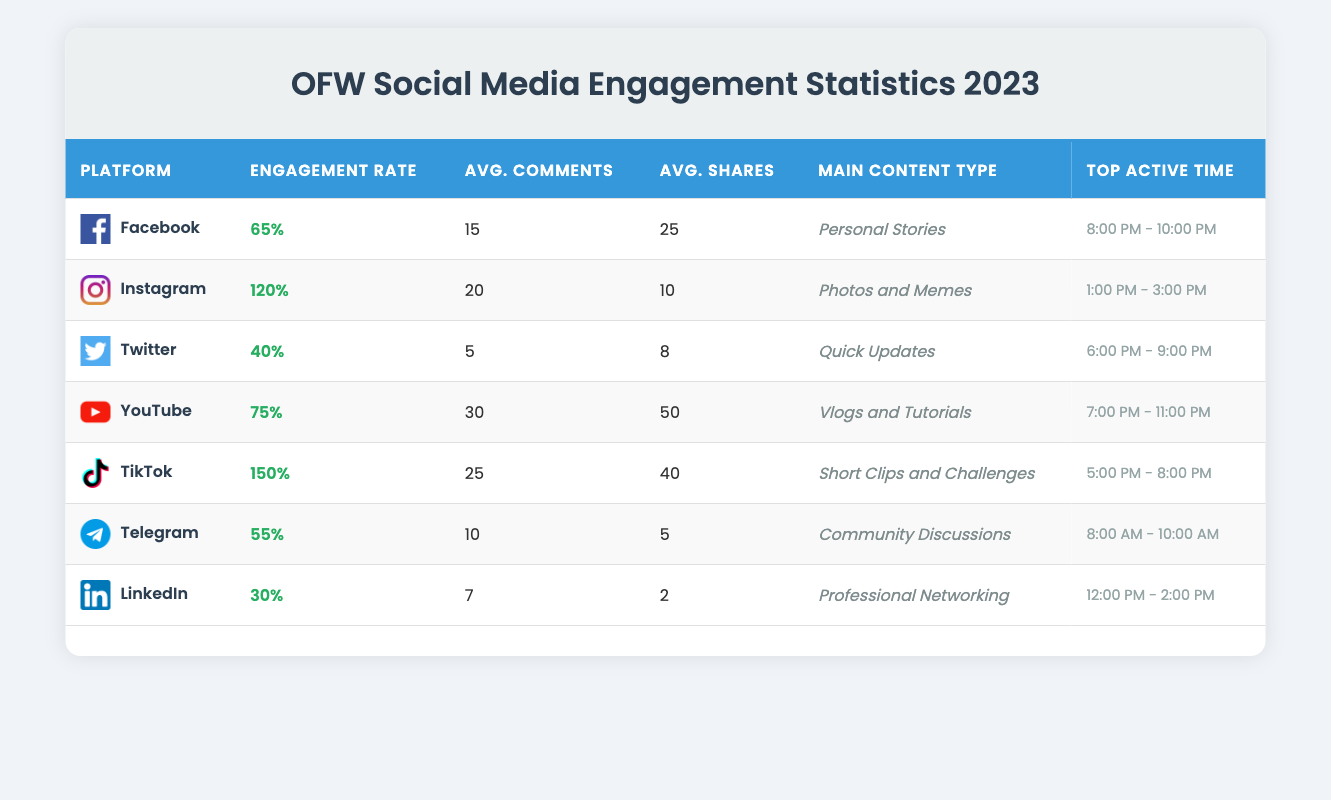What's the engagement rate for TikTok? Referring to the table, TikTok has an engagement rate listed as 1.5 or 150%.
Answer: 150% Which platform has the highest average comments per post? By examining the table, we see that YouTube has the highest average comments per video, which is 30.
Answer: 30 Is the main content type for Twitter quick updates? The table indicates that the main content type for Twitter is indeed Quick Updates.
Answer: Yes What is the average engagement rate for Facebook and Instagram combined? The engagement rates for Facebook and Instagram are 0.65 (65%) and 1.2 (120%), respectively. Summing these gives 0.65 + 1.2 = 1.85. To find the average, divide by 2: 1.85 / 2 = 0.925 or 92.5%.
Answer: 92.5% During which time range is Telegram most active? According to the table, Telegram's top active time is from 8:00 AM to 10:00 AM.
Answer: 8:00 AM - 10:00 AM How many average shares does YouTube have compared to LinkedIn? YouTube has an average of 50 shares per video, while LinkedIn has only 2 shares per post. To compare, 50 - 2 = 48 shares more on YouTube than on LinkedIn.
Answer: 48 more shares Which platforms have an engagement rate above 1? The platforms with engagement rates above 1 are Instagram (1.2) and TikTok (1.5). Thus, both of these platforms meet the criteria.
Answer: Instagram and TikTok Is the average shares per post for Facebook greater than that for Telegram? Facebook has an average of 25 shares while Telegram has only 5. Since 25 is greater than 5, the statement is true.
Answer: Yes 